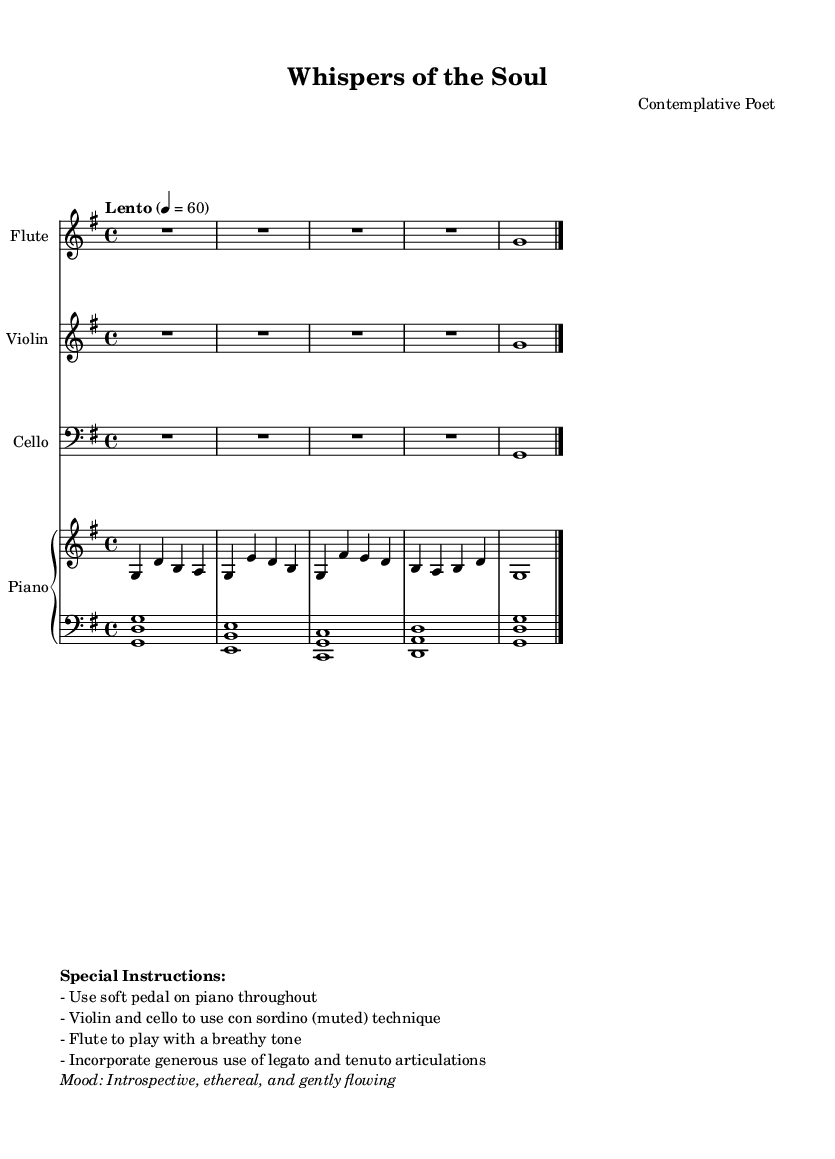What is the key signature of this music? The key signature is G major, which has one sharp (F#).
Answer: G major What is the time signature of this composition? The time signature is located at the beginning of the piece and shows that there are four beats in each measure.
Answer: 4/4 What is the indicated tempo? The tempo is indicated with the word "Lento" and a metronome marking of 60, which suggests a slow pace.
Answer: Lento, 60 Which instruments are featured in this piece? The score includes Flute, Violin, Cello, and Piano. Each instrument is listed at the beginning of their respective staves.
Answer: Flute, Violin, Cello, Piano How is the mood of the piece described? The mood is described in the special instructions section, emphasizing an introspective and ethereal feel.
Answer: Introspective, ethereal What technique is specified for the Violin and Cello? The instructions indicate that both the Violin and Cello are to use the con sordino technique, which means to play muted.
Answer: Con sordino What is the first note played by the piano? The first note in the right hand of the piano part is G, immediately following the treble clef sign.
Answer: G 